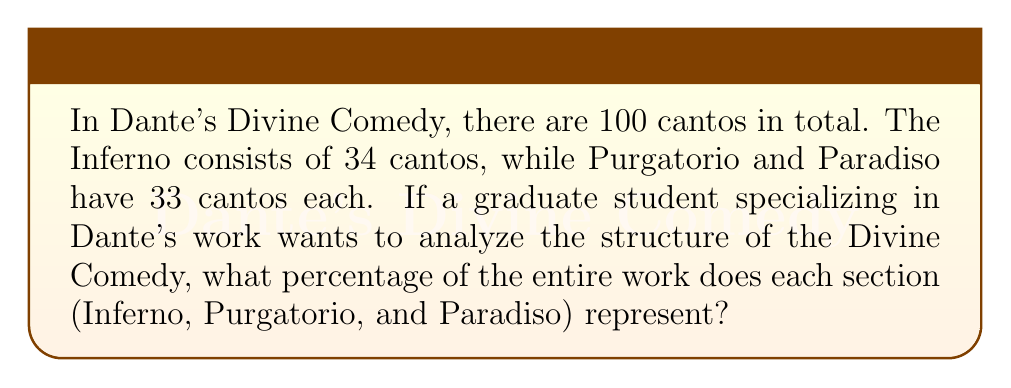What is the answer to this math problem? To solve this problem, we need to calculate the percentage of cantos for each section of the Divine Comedy. Let's break it down step by step:

1. First, let's recall the total number of cantos and the number in each section:
   - Total cantos: 100
   - Inferno: 34 cantos
   - Purgatorio: 33 cantos
   - Paradiso: 33 cantos

2. To calculate the percentage, we use the formula:
   $$ \text{Percentage} = \frac{\text{Number of cantos in section}}{\text{Total number of cantos}} \times 100\% $$

3. For Inferno:
   $$ \text{Percentage of Inferno} = \frac{34}{100} \times 100\% = 34\% $$

4. For Purgatorio:
   $$ \text{Percentage of Purgatorio} = \frac{33}{100} \times 100\% = 33\% $$

5. For Paradiso:
   $$ \text{Percentage of Paradiso} = \frac{33}{100} \times 100\% = 33\% $$

6. To verify our calculations, we can add up the percentages:
   $$ 34\% + 33\% + 33\% = 100\% $$

This confirms that our calculations are correct, as the sum of the percentages equals 100%.
Answer: Inferno: 34%
Purgatorio: 33%
Paradiso: 33% 